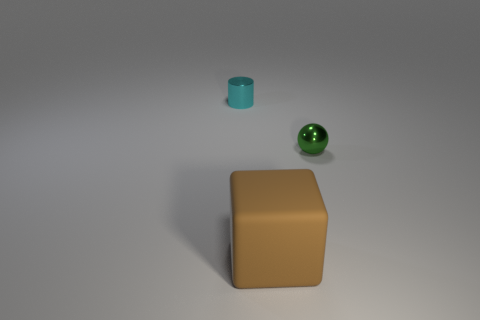Add 2 small brown matte cylinders. How many objects exist? 5 Subtract all spheres. How many objects are left? 2 Add 3 big cyan cylinders. How many big cyan cylinders exist? 3 Subtract 0 purple cubes. How many objects are left? 3 Subtract all small blue metallic blocks. Subtract all large rubber things. How many objects are left? 2 Add 1 brown things. How many brown things are left? 2 